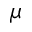<formula> <loc_0><loc_0><loc_500><loc_500>\mu</formula> 